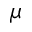<formula> <loc_0><loc_0><loc_500><loc_500>\mu</formula> 